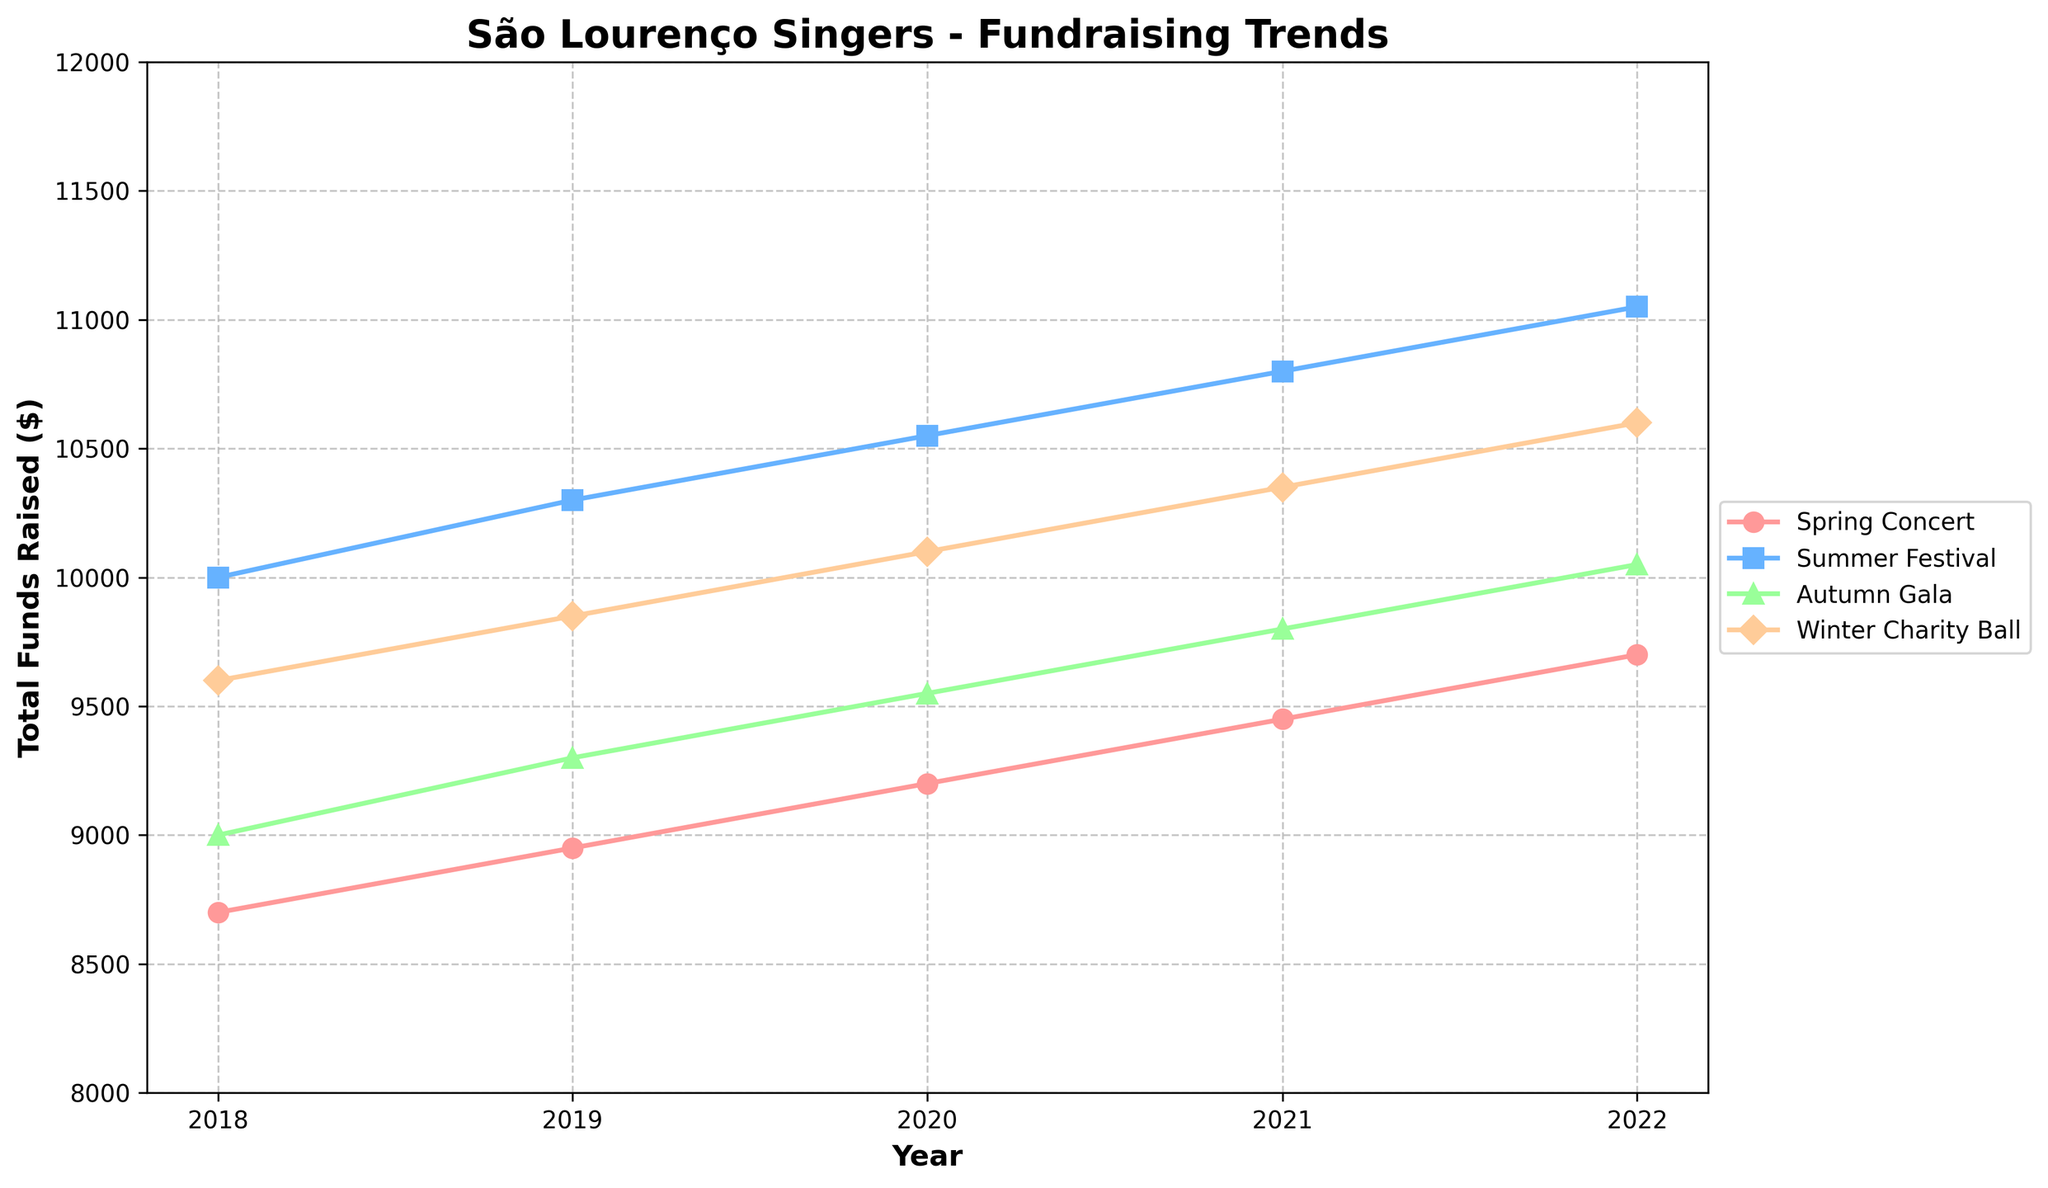What is the title of the chart? The title of the chart is displayed at the top and clearly reads "São Lourenço Singers - Fundraising Trends".
Answer: São Lourenço Singers - Fundraising Trends Which concert event raised the most funds in 2022? The 'Winter Charity Ball' raised the most funds in 2022 as it has the highest point on the y-axis for that year.
Answer: Winter Charity Ball How did the funds raised during the Autumn Gala change from 2018 to 2022? Looking at the plotted points for the Autumn Gala from 2018 to 2022, the total funds raised increased from $9000 to $10050.
Answer: Increased from $9000 to $10050 Which year shows the highest total funds raised for the Summer Festival? The highest total funds raised for the Summer Festival can be found by identifying the tallest point on the trend line for that event, which occurs in 2022 with $11050.
Answer: 2022 Compare the total funds raised for the Spring Concert between 2019 and 2021. Which year had a higher total? Comparing the points for the Spring Concert in 2019 and 2021, 2021 had a higher total funds raised ($9450) compared to 2019 ($8950).
Answer: 2021 What is the average total funds raised for the Winter Charity Ball over all the years shown? To find the average, sum the total funds raised for each year for the Winter Charity Ball and divide by the number of years: (9600 + 9850 + 10100 + 10350 + 10600) / 5 = 10100.
Answer: 10100 Was there any event where the total funds raised decreased continuously from 2018 to 2022? Observing all event lines, there is no event where the total funds raised continuously decreased each year from 2018 to 2022.
Answer: No Which event had the smallest increase in total funds raised from 2018 to 2022? By comparing the differences between 2018 and 2022 for each event: Spring Concert (400), Summer Festival (1050), Autumn Gala (1050), and Winter Charity Ball (1000), the Spring Concert had the smallest increase.
Answer: Spring Concert Did the total funds raised for the Summer Festival always increase each year? Examining the trend line for the Summer Festival, the total funds raised increased every year from 2018 to 2022.
Answer: Yes 